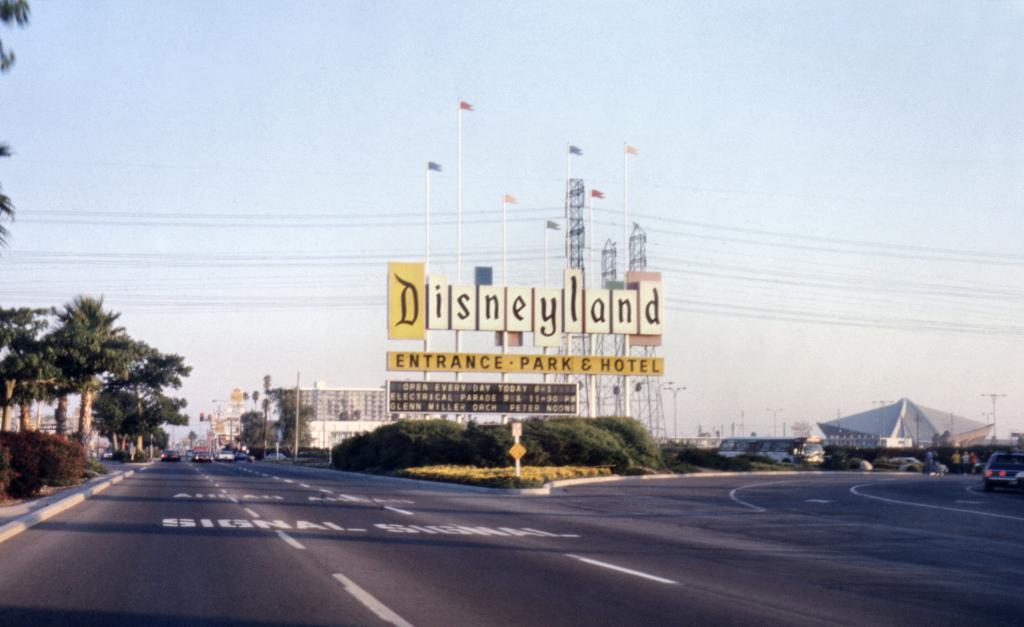Describe this image in one or two sentences. In this picture I can see trees. I can see green grass. I can see the vehicles on the road. I can see electric wires. I can see electric poles. I can see hoardings. I can see the buildings. I can see clouds in the sky. 